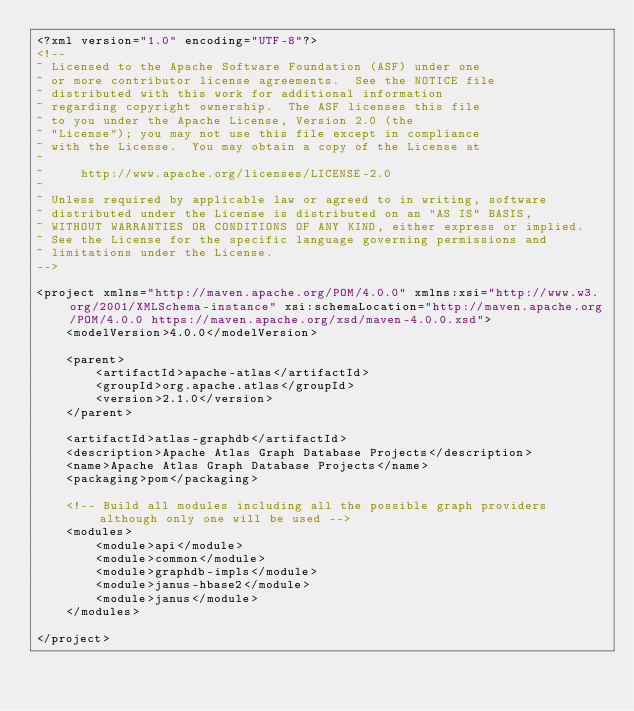<code> <loc_0><loc_0><loc_500><loc_500><_XML_><?xml version="1.0" encoding="UTF-8"?>
<!--
~ Licensed to the Apache Software Foundation (ASF) under one
~ or more contributor license agreements.  See the NOTICE file
~ distributed with this work for additional information
~ regarding copyright ownership.  The ASF licenses this file
~ to you under the Apache License, Version 2.0 (the
~ "License"); you may not use this file except in compliance
~ with the License.  You may obtain a copy of the License at
~
~     http://www.apache.org/licenses/LICENSE-2.0
~
~ Unless required by applicable law or agreed to in writing, software
~ distributed under the License is distributed on an "AS IS" BASIS,
~ WITHOUT WARRANTIES OR CONDITIONS OF ANY KIND, either express or implied.
~ See the License for the specific language governing permissions and
~ limitations under the License.
-->

<project xmlns="http://maven.apache.org/POM/4.0.0" xmlns:xsi="http://www.w3.org/2001/XMLSchema-instance" xsi:schemaLocation="http://maven.apache.org/POM/4.0.0 https://maven.apache.org/xsd/maven-4.0.0.xsd">
    <modelVersion>4.0.0</modelVersion>

    <parent>
        <artifactId>apache-atlas</artifactId>
        <groupId>org.apache.atlas</groupId>
        <version>2.1.0</version>
    </parent>

    <artifactId>atlas-graphdb</artifactId>
    <description>Apache Atlas Graph Database Projects</description>
    <name>Apache Atlas Graph Database Projects</name>
    <packaging>pom</packaging>

    <!-- Build all modules including all the possible graph providers although only one will be used -->
    <modules>
        <module>api</module>
        <module>common</module>
        <module>graphdb-impls</module>
        <module>janus-hbase2</module>
        <module>janus</module>
    </modules>

</project>
</code> 